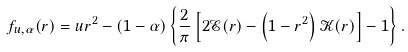<formula> <loc_0><loc_0><loc_500><loc_500>f _ { u , \alpha } ( r ) = u r ^ { 2 } - ( 1 - \alpha ) \left \{ \frac { 2 } { \pi } \left [ 2 \mathcal { E } ( r ) - \left ( 1 - r ^ { 2 } \right ) \mathcal { K } ( r ) \right ] - 1 \right \} .</formula> 